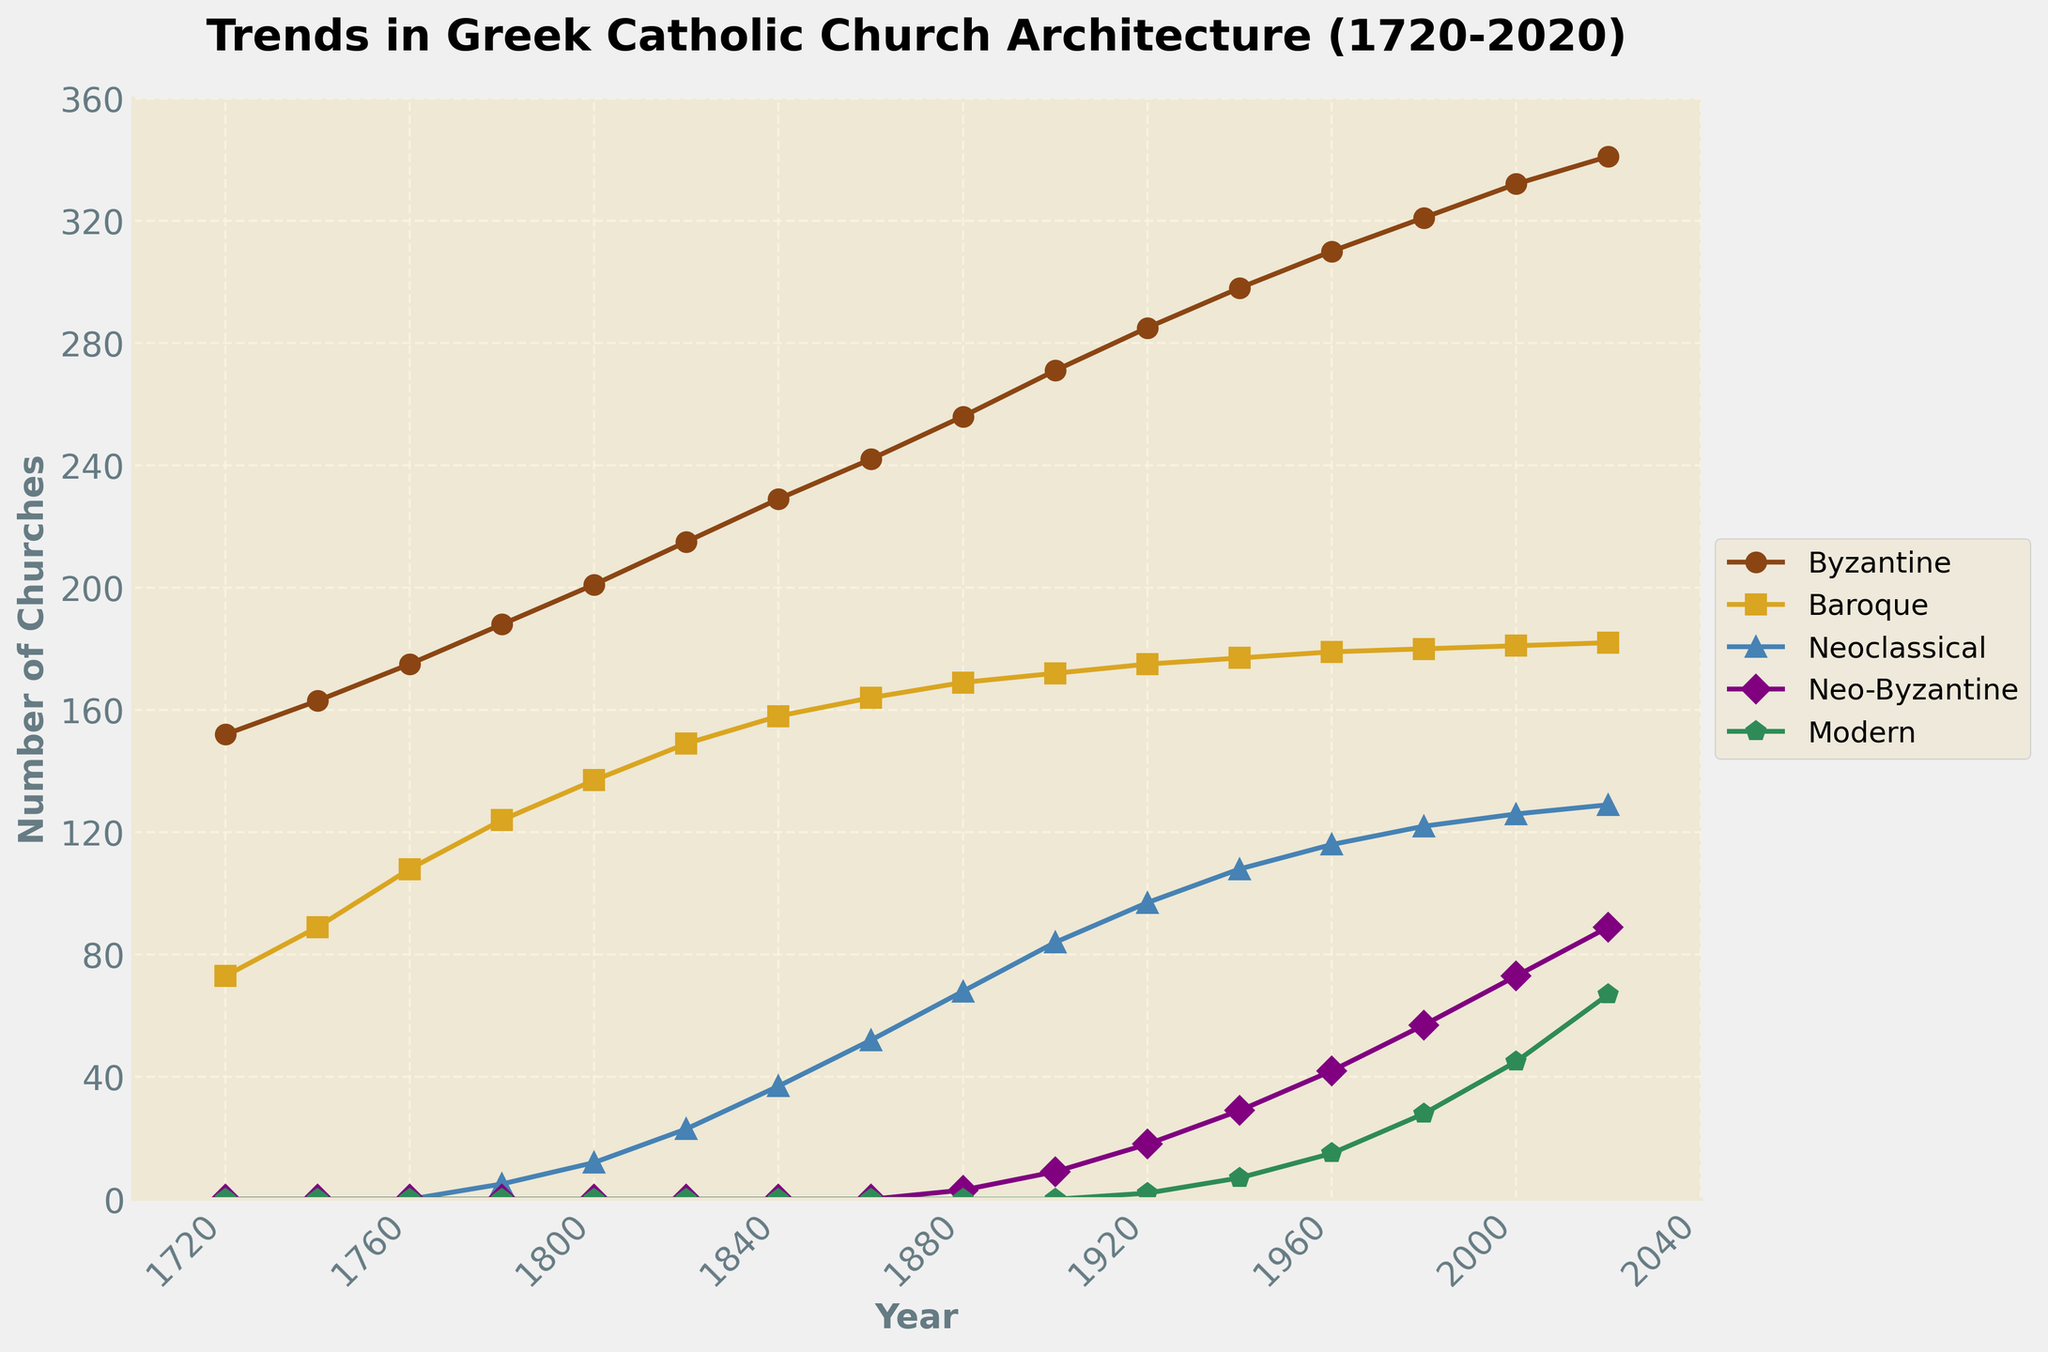What architectural style saw the highest number of churches built in the year 2020? First, identify the data line for the year 2020. Then, compare the values for each architectural style. Byzantine has the highest peak.
Answer: Byzantine Between which years did the Byzantine style see the greatest increase in the number of churches built? Examine the slope of the Byzantine line. The steepest increase appears between 1720 and 1760.
Answer: 1720-1760 How does the growth rate of Baroque churches between 1800 and 1840 compare to that of Neoclassical churches in the same period? Calculate the increase for both styles: Baroque from 137 to 158 (21), Neoclassical from 12 to 37 (25). Neoclassical had a higher growth rate than Baroque.
Answer: Neoclassical By how much did the number of Neo-Byzantine churches increase from 1960 to 2000? Identify the values for 1960 (42) and 2000 (73), then subtract to find the difference: 73 - 42 = 31.
Answer: 31 Which architectural style had the least variability in the number of churches built throughout 1720-2020? Compare the fluctuations in each line. Modern shows less overall variability.
Answer: Modern What are the visual characteristics of the line representing the Modern architectural style? The Modern line is visually represented by a green color and pentagon markers.
Answer: Green, pentagon markers Compare the number of Neoclassical churches built in 1900 and 2020. What is the difference? For 1900, the number is 84, and for 2020, it is 129. The difference is 129 - 84 = 45.
Answer: 45 What is the total number of churches built of all architectural styles in 1980? Sum up the values for 1980: 321(Byzantine) + 180(Baroque) + 122(Neoclassical) + 57(Neo-Byzantine) + 28(Modern) = 708.
Answer: 708 Which architectural style had the fewest changes in church construction numbers from 2000 to 2020? Compare the difference for each style between 2000 and 2020. The Baroque style had the smallest increase (1).
Answer: Baroque 